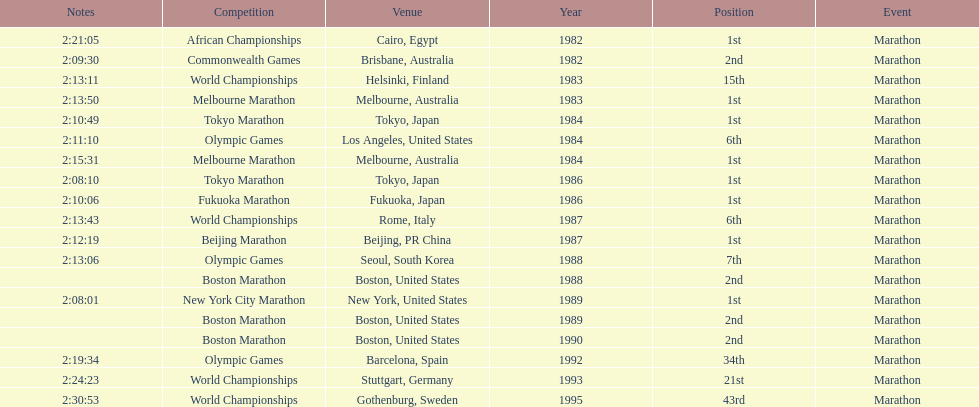What was the exclusive competition to transpire in china? Beijing Marathon. 